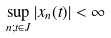Convert formula to latex. <formula><loc_0><loc_0><loc_500><loc_500>\sup _ { n ; t \in J } | x _ { n } ( t ) | < \infty</formula> 